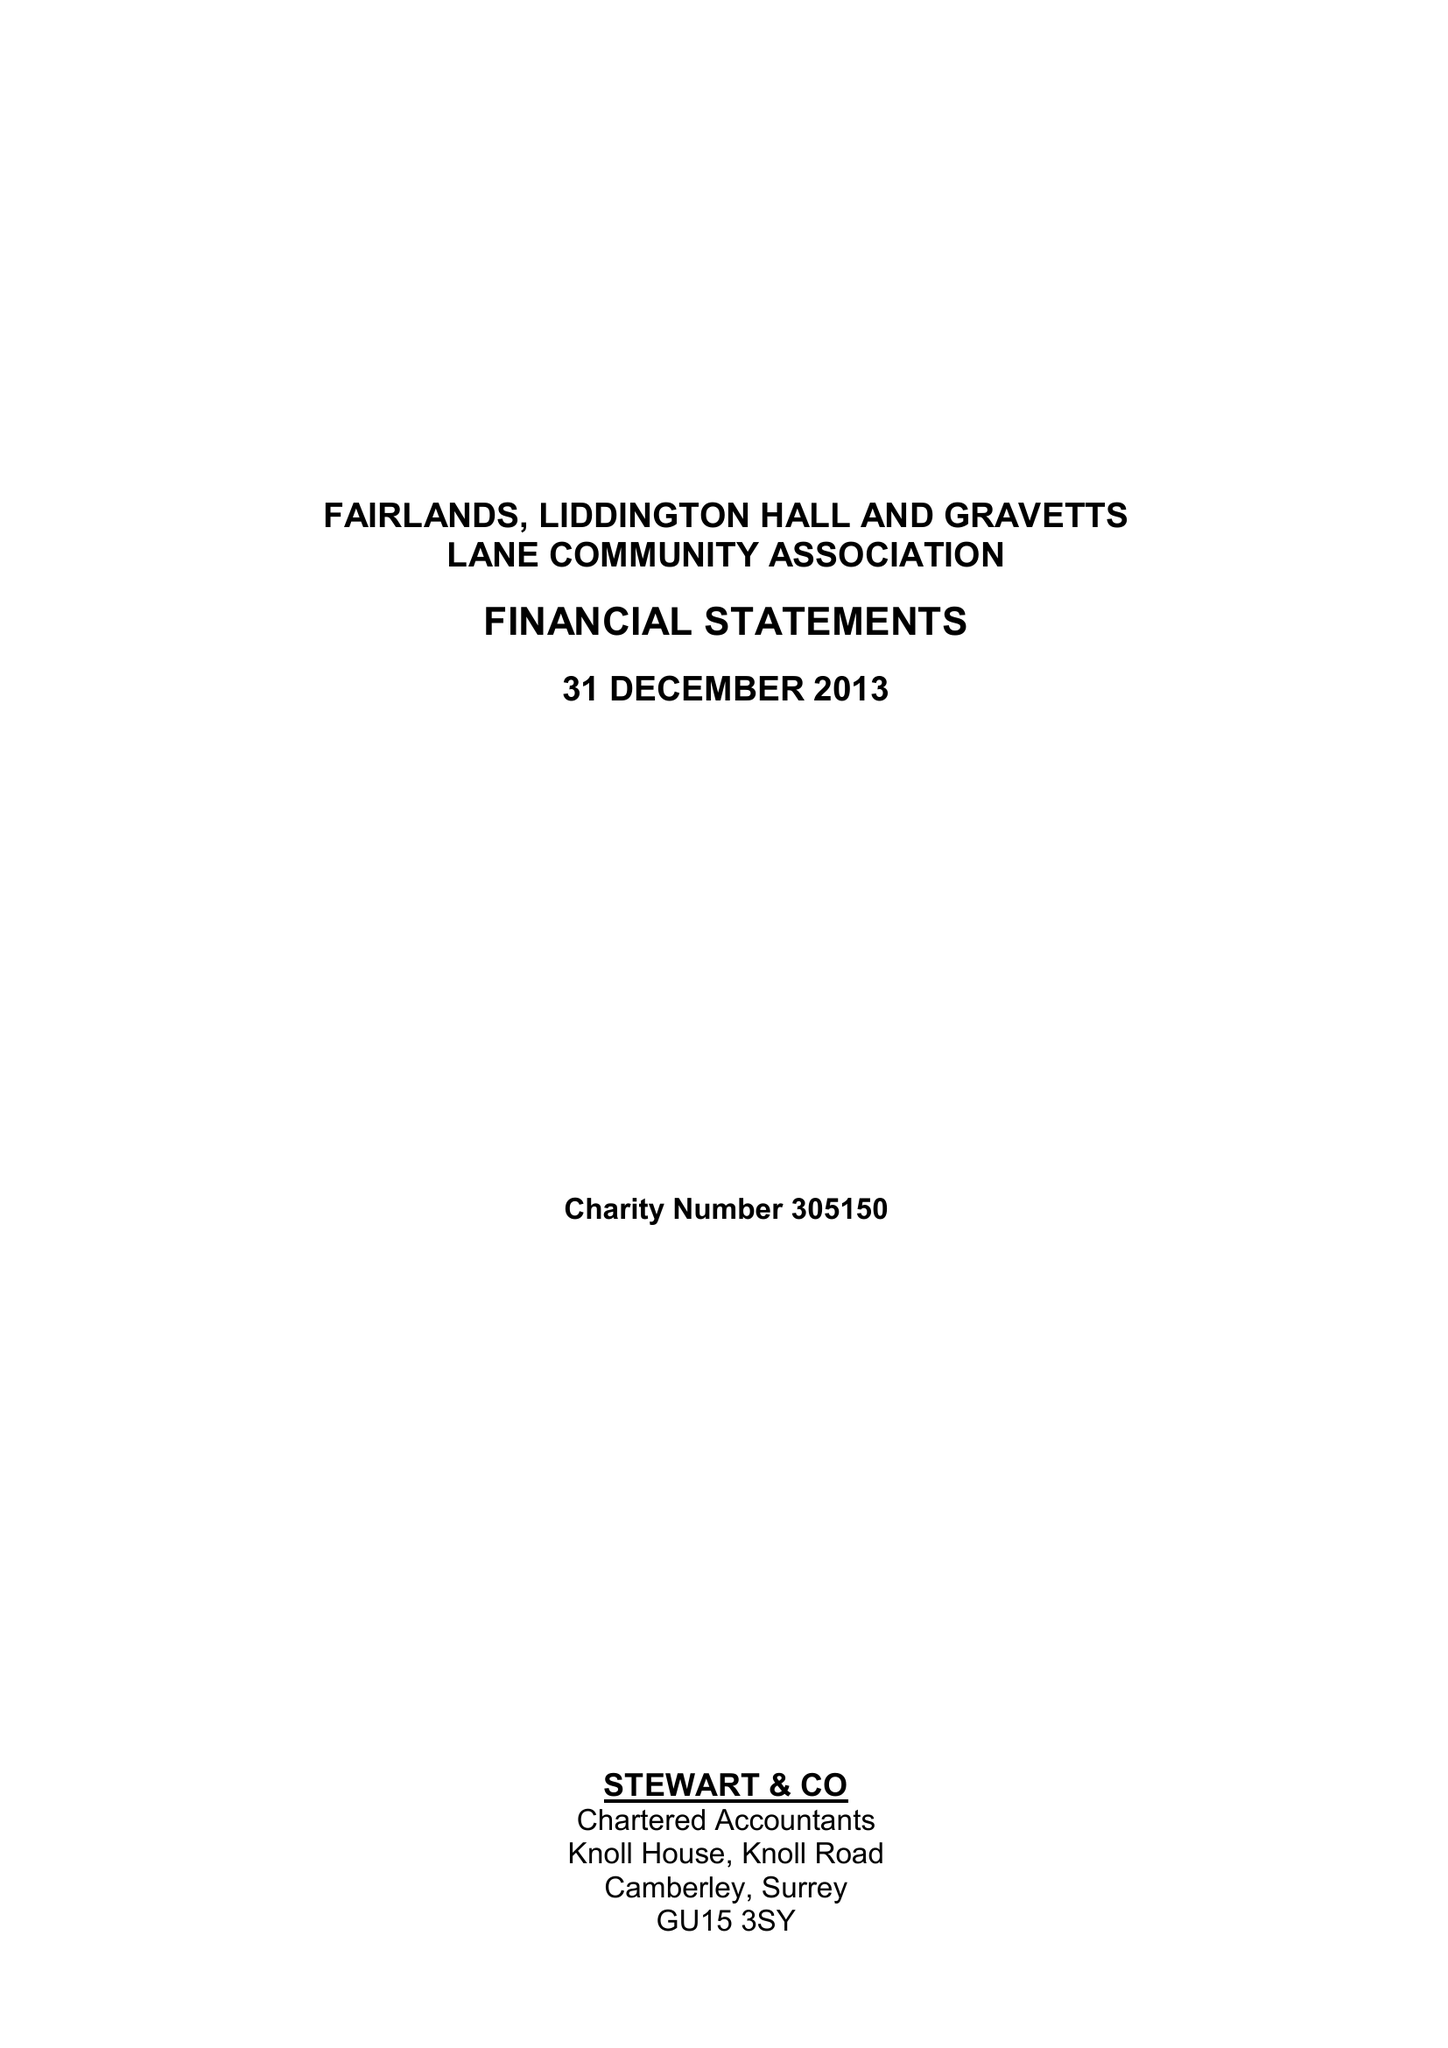What is the value for the address__street_line?
Answer the question using a single word or phrase. None 